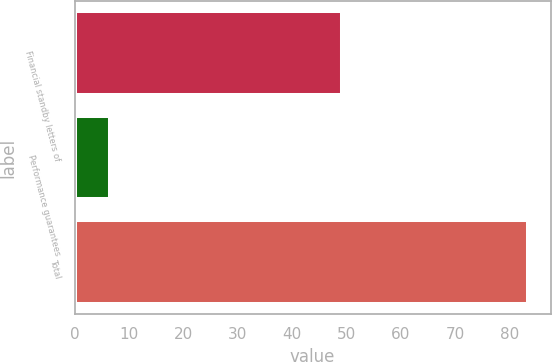<chart> <loc_0><loc_0><loc_500><loc_500><bar_chart><fcel>Financial standby letters of<fcel>Performance guarantees<fcel>Total<nl><fcel>49.2<fcel>6.5<fcel>83.4<nl></chart> 